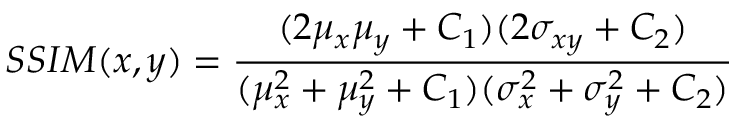Convert formula to latex. <formula><loc_0><loc_0><loc_500><loc_500>S S I M ( x , y ) = \frac { ( 2 \mu _ { x } \mu _ { y } + C _ { 1 } ) ( 2 \sigma _ { x y } + C _ { 2 } ) } { ( \mu _ { x } ^ { 2 } + \mu _ { y } ^ { 2 } + C _ { 1 } ) ( \sigma _ { x } ^ { 2 } + \sigma _ { y } ^ { 2 } + C _ { 2 } ) } \,</formula> 